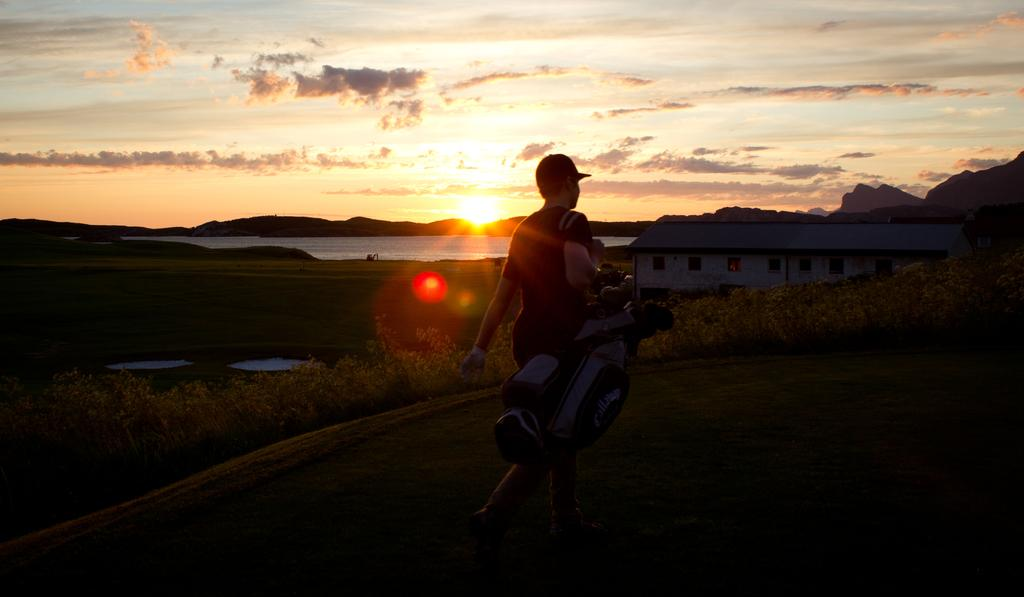What is the main subject of the image? There is a person in the image. What is the person wearing? The person is wearing a black dress. What is the person carrying? The person is carrying a bag. What can be seen in the background of the image? There are plants, a building, water, and mountains visible in the background of the image. What type of light can be seen shining on the person in the image? There is no specific light source mentioned in the facts, so we cannot determine the type of light shining on the person in the image. 